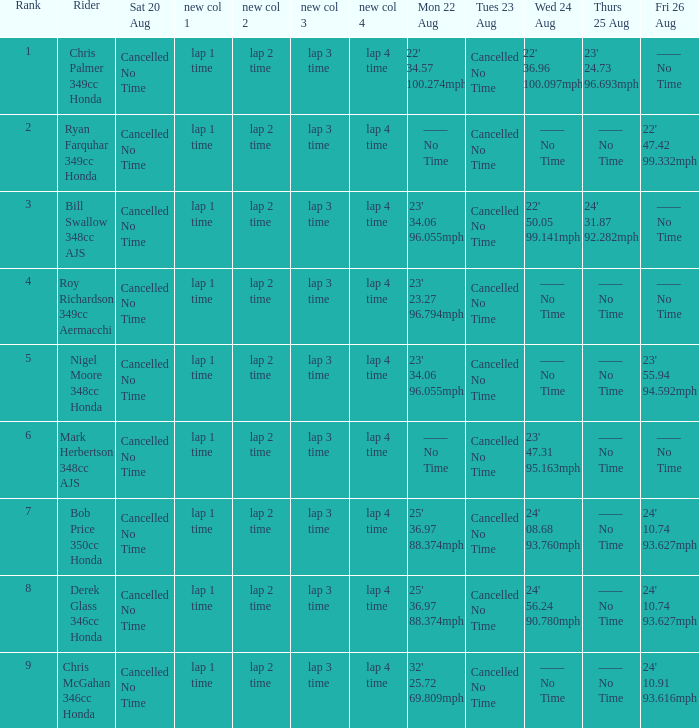What is every value on Thursday August 25 for rank 3? 24' 31.87 92.282mph. 